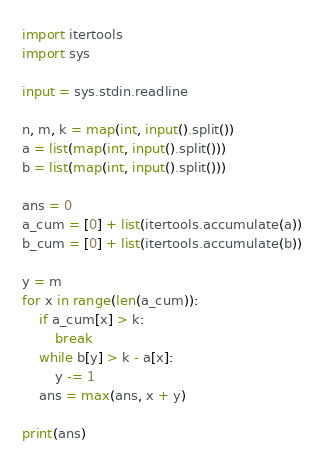<code> <loc_0><loc_0><loc_500><loc_500><_Python_>import itertools
import sys

input = sys.stdin.readline

n, m, k = map(int, input().split())
a = list(map(int, input().split()))
b = list(map(int, input().split()))

ans = 0
a_cum = [0] + list(itertools.accumulate(a))
b_cum = [0] + list(itertools.accumulate(b))

y = m
for x in range(len(a_cum)):
    if a_cum[x] > k:
        break
    while b[y] > k - a[x]:
        y -= 1
    ans = max(ans, x + y)

print(ans)
</code> 